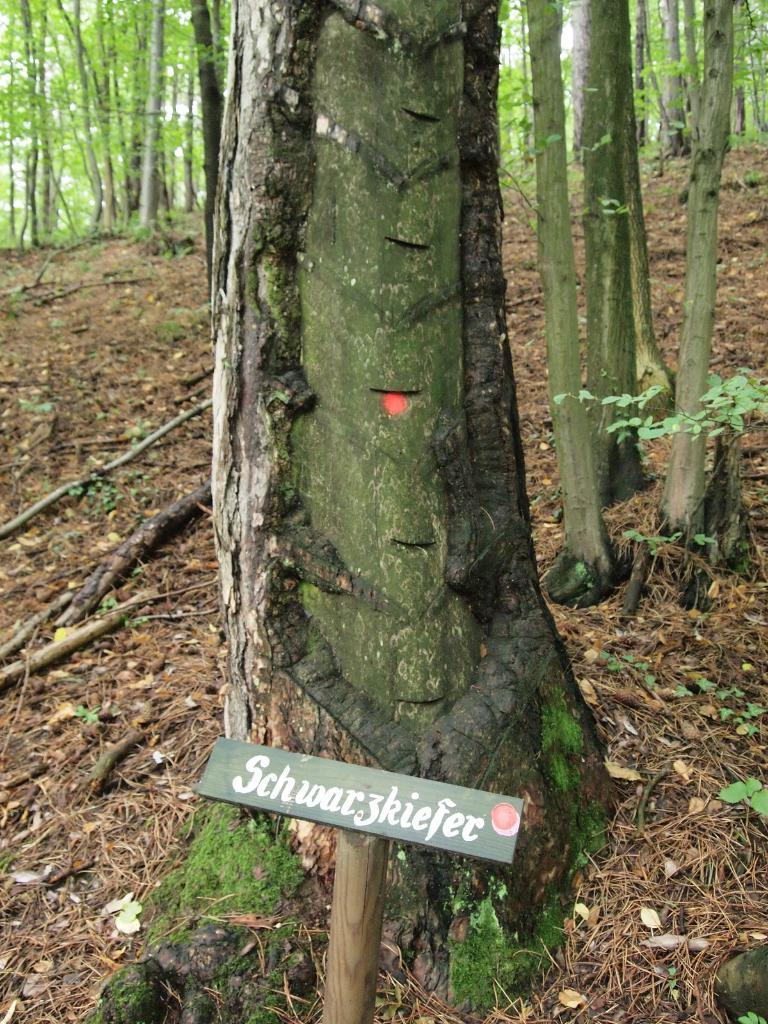What object is present in the image that is black in color? There is a black board in the image. How is the black board attached to another object? The black board is attached to a wooden stick. What can be seen in the background of the image? There are trees and the sky visible in the background of the image. What color are the trees in the image? The trees are green in color. What color is the sky in the image? The sky is white in color. How low is the base of the star in the image? There is no star present in the image, so it is not possible to determine the height of its base. 